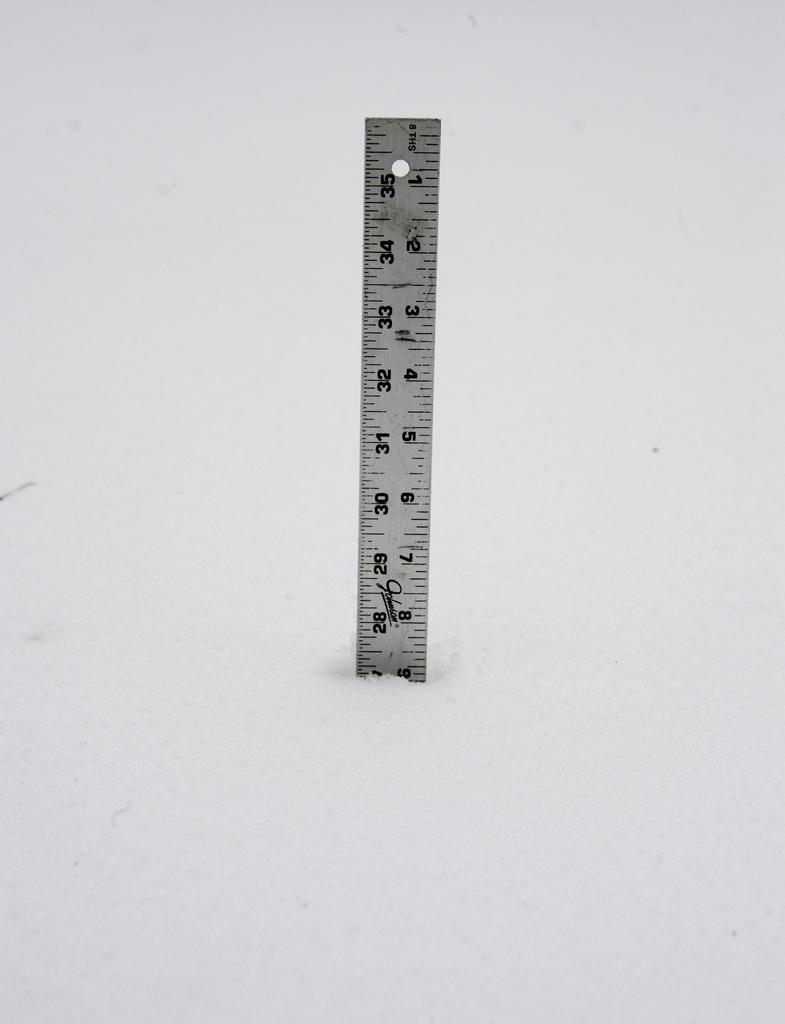What is the highest number on the ruler?
Your answer should be compact. 35. What is the middle number on the ruler?
Offer a very short reply. 31. 